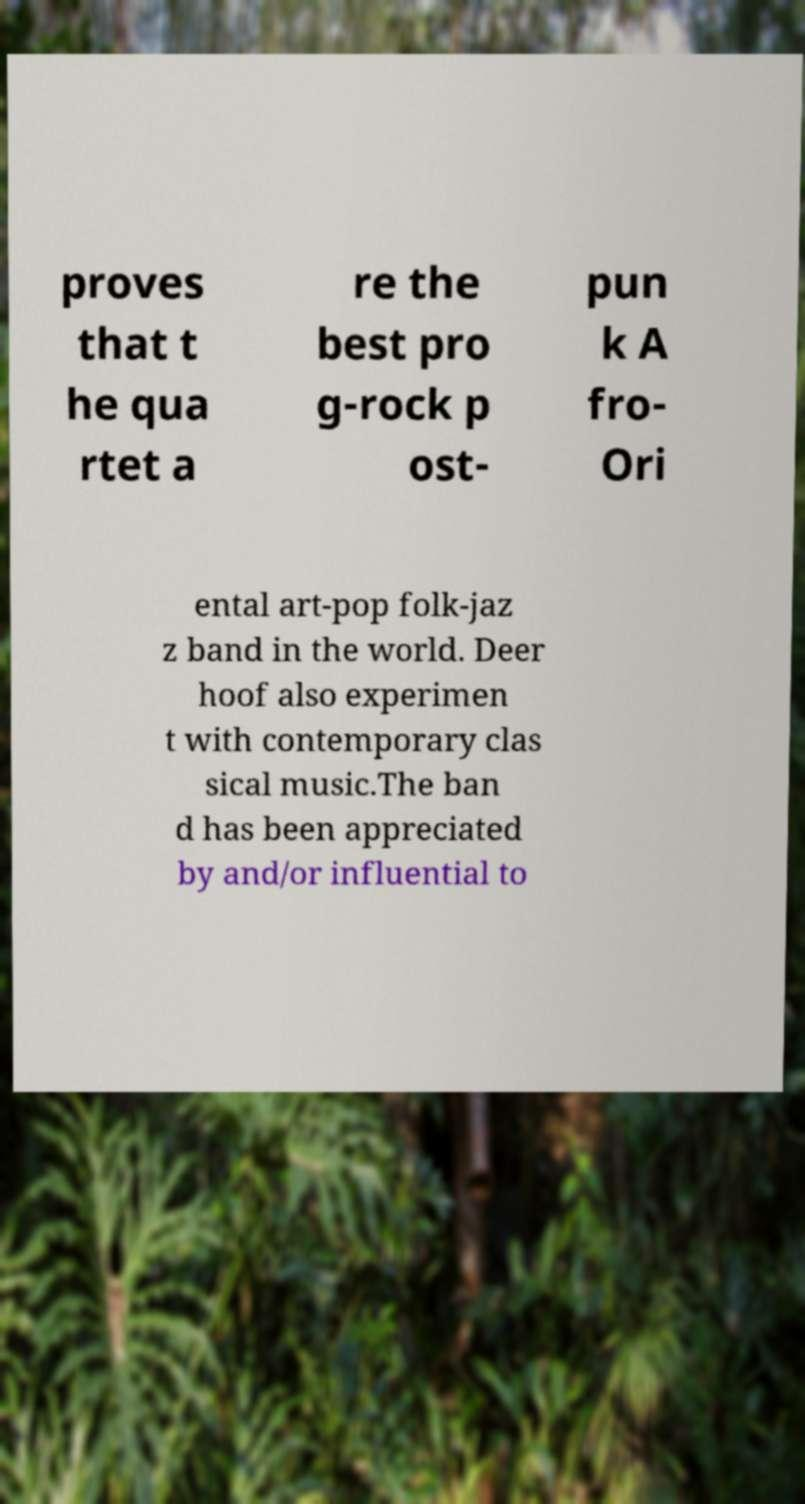Please read and relay the text visible in this image. What does it say? proves that t he qua rtet a re the best pro g-rock p ost- pun k A fro- Ori ental art-pop folk-jaz z band in the world. Deer hoof also experimen t with contemporary clas sical music.The ban d has been appreciated by and/or influential to 